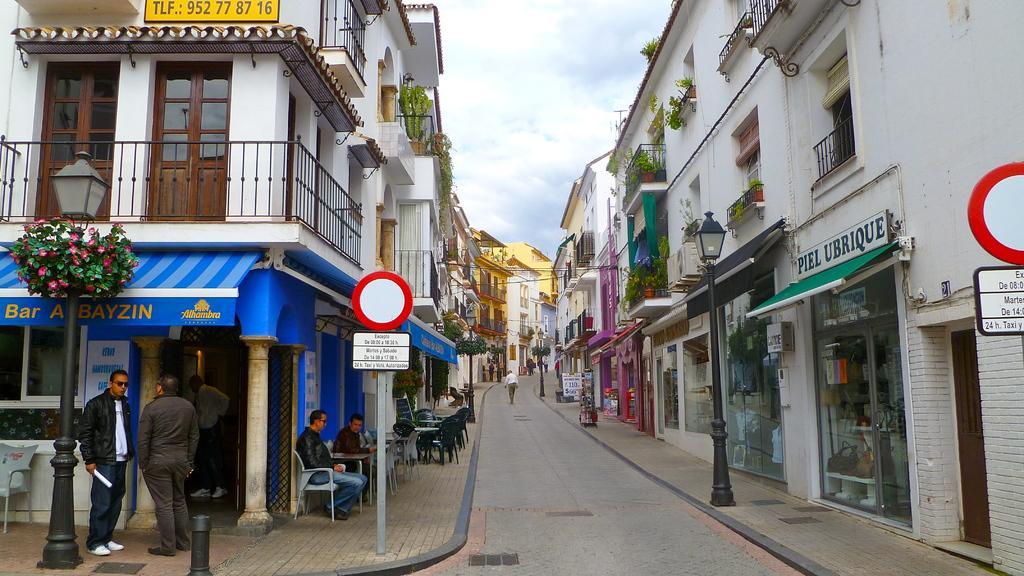Please provide a concise description of this image. In this image we can see buildings, poles, boards, plants, flowers, fence, chairs, tables, and people. Here we can see a road. In the background there is sky with clouds. 